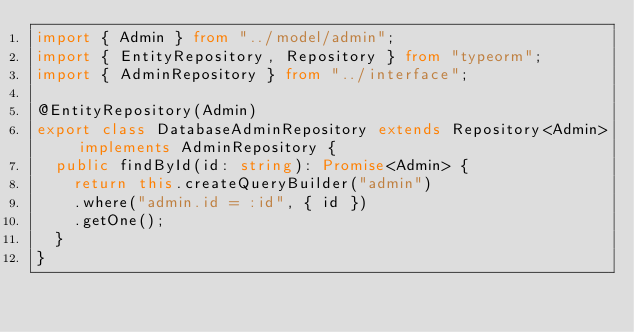<code> <loc_0><loc_0><loc_500><loc_500><_TypeScript_>import { Admin } from "../model/admin";
import { EntityRepository, Repository } from "typeorm";
import { AdminRepository } from "../interface";

@EntityRepository(Admin) 
export class DatabaseAdminRepository extends Repository<Admin> implements AdminRepository {
  public findById(id: string): Promise<Admin> {
    return this.createQueryBuilder("admin")
    .where("admin.id = :id", { id })
    .getOne();
  }
}</code> 